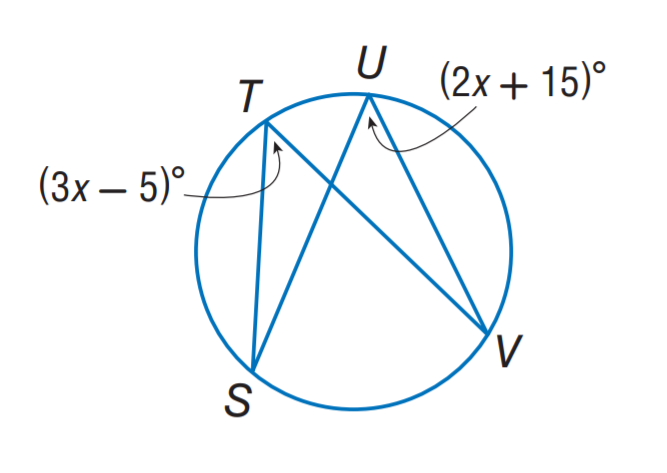Answer the mathemtical geometry problem and directly provide the correct option letter.
Question: Find m \angle T.
Choices: A: 15 B: 35 C: 55 D: 60 C 